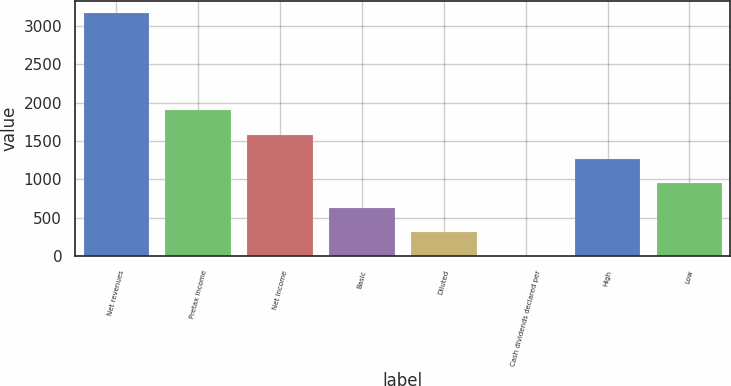Convert chart. <chart><loc_0><loc_0><loc_500><loc_500><bar_chart><fcel>Net revenues<fcel>Pretax income<fcel>Net income<fcel>Basic<fcel>Diluted<fcel>Cash dividends declared per<fcel>High<fcel>Low<nl><fcel>3160<fcel>1896.35<fcel>1580.43<fcel>632.67<fcel>316.75<fcel>0.83<fcel>1264.51<fcel>948.59<nl></chart> 